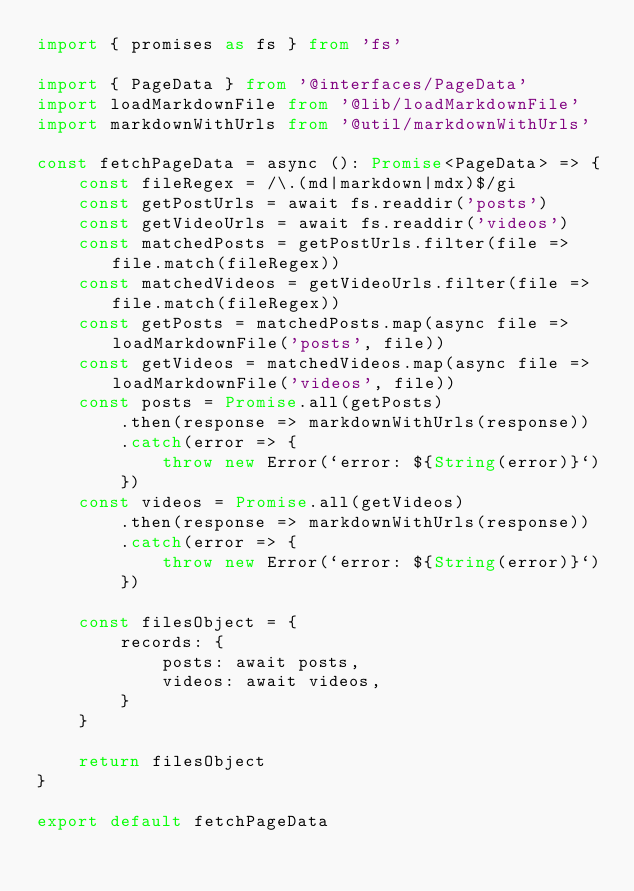Convert code to text. <code><loc_0><loc_0><loc_500><loc_500><_TypeScript_>import { promises as fs } from 'fs'

import { PageData } from '@interfaces/PageData'
import loadMarkdownFile from '@lib/loadMarkdownFile'
import markdownWithUrls from '@util/markdownWithUrls'

const fetchPageData = async (): Promise<PageData> => {
    const fileRegex = /\.(md|markdown|mdx)$/gi
    const getPostUrls = await fs.readdir('posts')
    const getVideoUrls = await fs.readdir('videos')
    const matchedPosts = getPostUrls.filter(file => file.match(fileRegex))
    const matchedVideos = getVideoUrls.filter(file => file.match(fileRegex))
    const getPosts = matchedPosts.map(async file => loadMarkdownFile('posts', file))
    const getVideos = matchedVideos.map(async file => loadMarkdownFile('videos', file))
    const posts = Promise.all(getPosts)
        .then(response => markdownWithUrls(response))
        .catch(error => {
            throw new Error(`error: ${String(error)}`)
        })
    const videos = Promise.all(getVideos)
        .then(response => markdownWithUrls(response))
        .catch(error => {
            throw new Error(`error: ${String(error)}`)
        })

    const filesObject = {
        records: {
            posts: await posts,
            videos: await videos,
        }
    }
    
    return filesObject
}

export default fetchPageData
</code> 